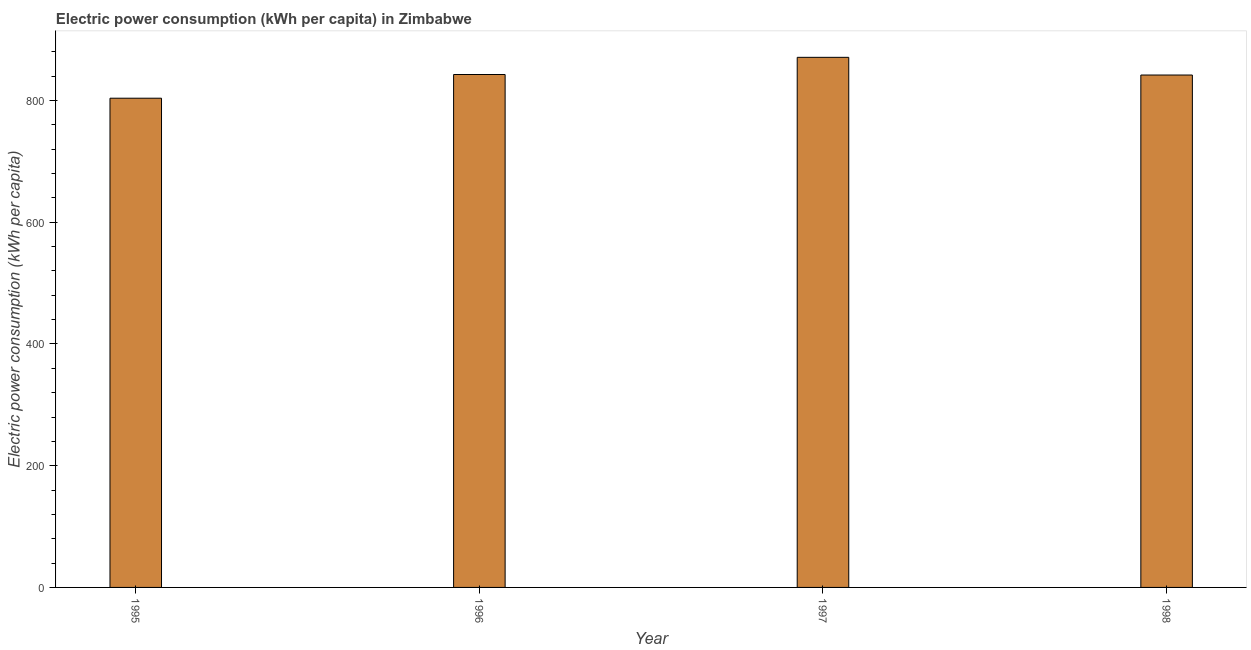Does the graph contain any zero values?
Ensure brevity in your answer.  No. Does the graph contain grids?
Ensure brevity in your answer.  No. What is the title of the graph?
Provide a succinct answer. Electric power consumption (kWh per capita) in Zimbabwe. What is the label or title of the Y-axis?
Give a very brief answer. Electric power consumption (kWh per capita). What is the electric power consumption in 1996?
Provide a short and direct response. 842.76. Across all years, what is the maximum electric power consumption?
Make the answer very short. 870.99. Across all years, what is the minimum electric power consumption?
Offer a very short reply. 803.81. In which year was the electric power consumption maximum?
Your response must be concise. 1997. What is the sum of the electric power consumption?
Your answer should be compact. 3359.48. What is the difference between the electric power consumption in 1996 and 1997?
Your response must be concise. -28.23. What is the average electric power consumption per year?
Your answer should be very brief. 839.87. What is the median electric power consumption?
Provide a short and direct response. 842.34. Do a majority of the years between 1997 and 1996 (inclusive) have electric power consumption greater than 760 kWh per capita?
Provide a short and direct response. No. Is the electric power consumption in 1995 less than that in 1997?
Offer a very short reply. Yes. What is the difference between the highest and the second highest electric power consumption?
Offer a very short reply. 28.23. Is the sum of the electric power consumption in 1995 and 1996 greater than the maximum electric power consumption across all years?
Give a very brief answer. Yes. What is the difference between the highest and the lowest electric power consumption?
Your response must be concise. 67.18. How many bars are there?
Provide a short and direct response. 4. How many years are there in the graph?
Offer a very short reply. 4. What is the Electric power consumption (kWh per capita) in 1995?
Give a very brief answer. 803.81. What is the Electric power consumption (kWh per capita) of 1996?
Provide a short and direct response. 842.76. What is the Electric power consumption (kWh per capita) in 1997?
Your response must be concise. 870.99. What is the Electric power consumption (kWh per capita) of 1998?
Your answer should be very brief. 841.93. What is the difference between the Electric power consumption (kWh per capita) in 1995 and 1996?
Your answer should be compact. -38.95. What is the difference between the Electric power consumption (kWh per capita) in 1995 and 1997?
Provide a succinct answer. -67.18. What is the difference between the Electric power consumption (kWh per capita) in 1995 and 1998?
Keep it short and to the point. -38.12. What is the difference between the Electric power consumption (kWh per capita) in 1996 and 1997?
Make the answer very short. -28.23. What is the difference between the Electric power consumption (kWh per capita) in 1996 and 1998?
Offer a very short reply. 0.83. What is the difference between the Electric power consumption (kWh per capita) in 1997 and 1998?
Make the answer very short. 29.06. What is the ratio of the Electric power consumption (kWh per capita) in 1995 to that in 1996?
Provide a succinct answer. 0.95. What is the ratio of the Electric power consumption (kWh per capita) in 1995 to that in 1997?
Give a very brief answer. 0.92. What is the ratio of the Electric power consumption (kWh per capita) in 1995 to that in 1998?
Give a very brief answer. 0.95. What is the ratio of the Electric power consumption (kWh per capita) in 1996 to that in 1997?
Provide a short and direct response. 0.97. What is the ratio of the Electric power consumption (kWh per capita) in 1997 to that in 1998?
Your response must be concise. 1.03. 